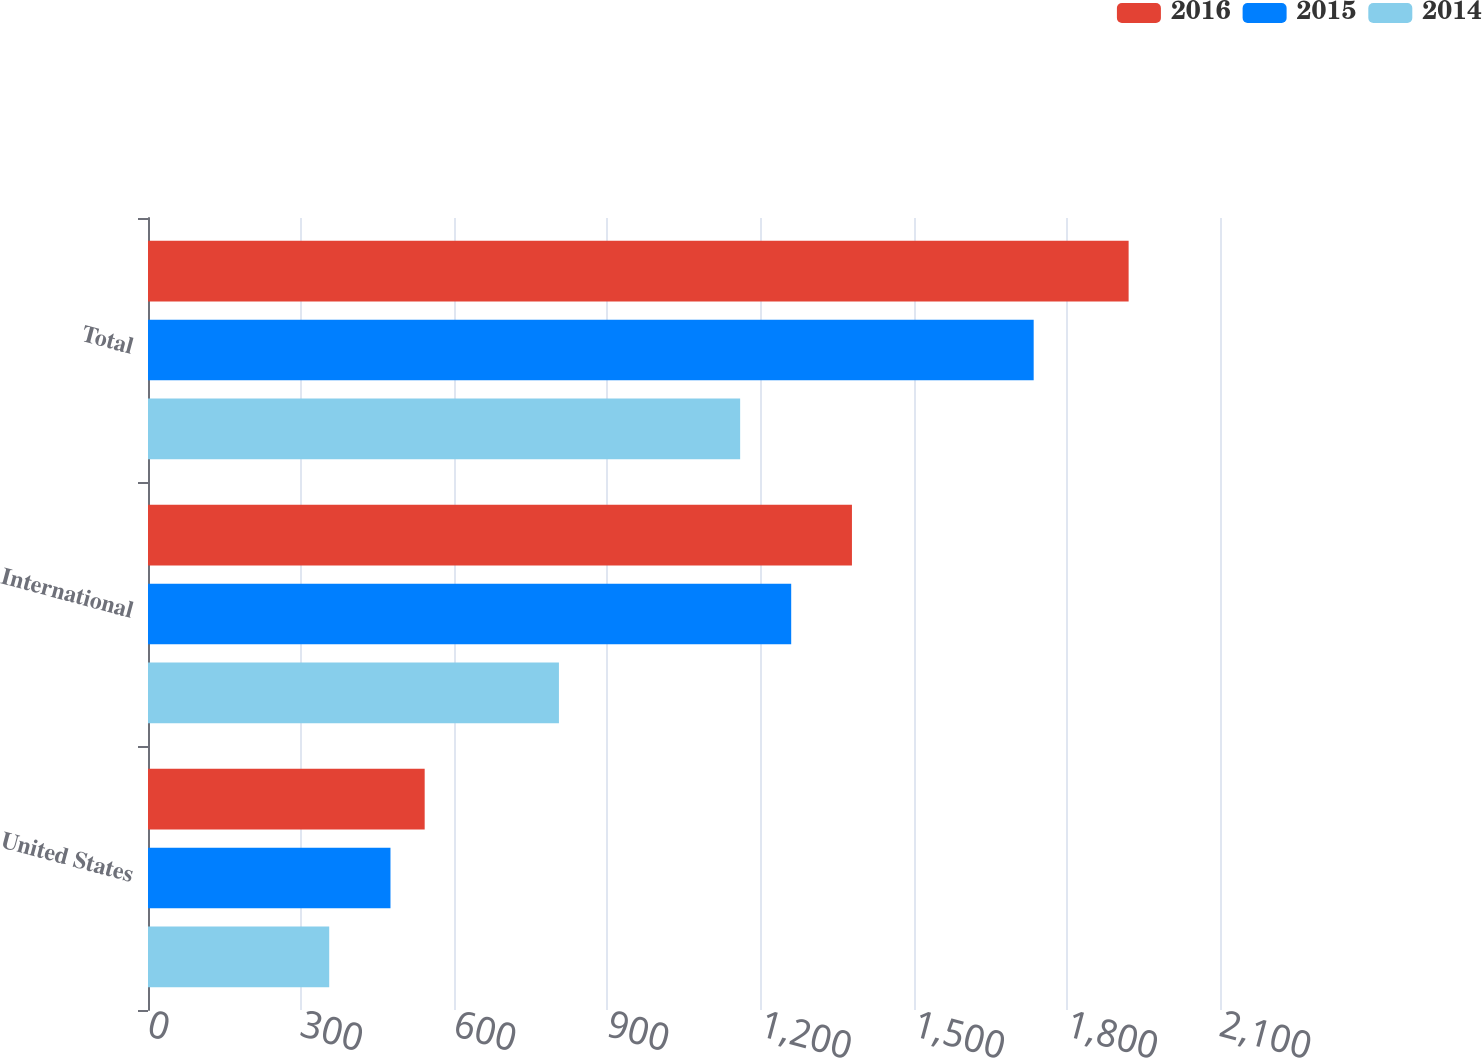<chart> <loc_0><loc_0><loc_500><loc_500><stacked_bar_chart><ecel><fcel>United States<fcel>International<fcel>Total<nl><fcel>2016<fcel>542<fcel>1379<fcel>1921<nl><fcel>2015<fcel>475<fcel>1260<fcel>1735<nl><fcel>2014<fcel>355<fcel>805<fcel>1160<nl></chart> 